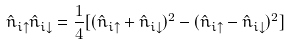Convert formula to latex. <formula><loc_0><loc_0><loc_500><loc_500>\hat { n } _ { i \uparrow } \hat { n } _ { i \downarrow } = \frac { 1 } { 4 } [ ( \hat { n } _ { i \uparrow } + \hat { n } _ { i \downarrow } ) ^ { 2 } - ( \hat { n } _ { i \uparrow } - \hat { n } _ { i \downarrow } ) ^ { 2 } ]</formula> 